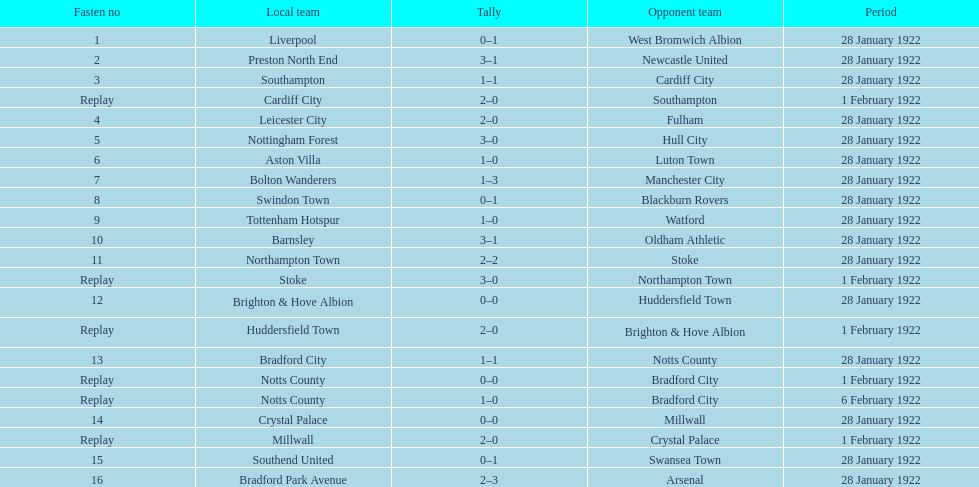How many games had four total points scored or more? 5. 